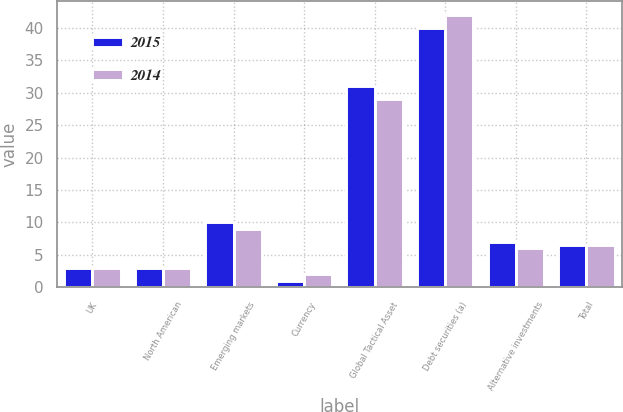Convert chart to OTSL. <chart><loc_0><loc_0><loc_500><loc_500><stacked_bar_chart><ecel><fcel>UK<fcel>North American<fcel>Emerging markets<fcel>Currency<fcel>Global Tactical Asset<fcel>Debt securities (a)<fcel>Alternative investments<fcel>Total<nl><fcel>2015<fcel>3<fcel>3<fcel>10<fcel>1<fcel>31<fcel>40<fcel>7<fcel>6.5<nl><fcel>2014<fcel>3<fcel>3<fcel>9<fcel>2<fcel>29<fcel>42<fcel>6<fcel>6.5<nl></chart> 